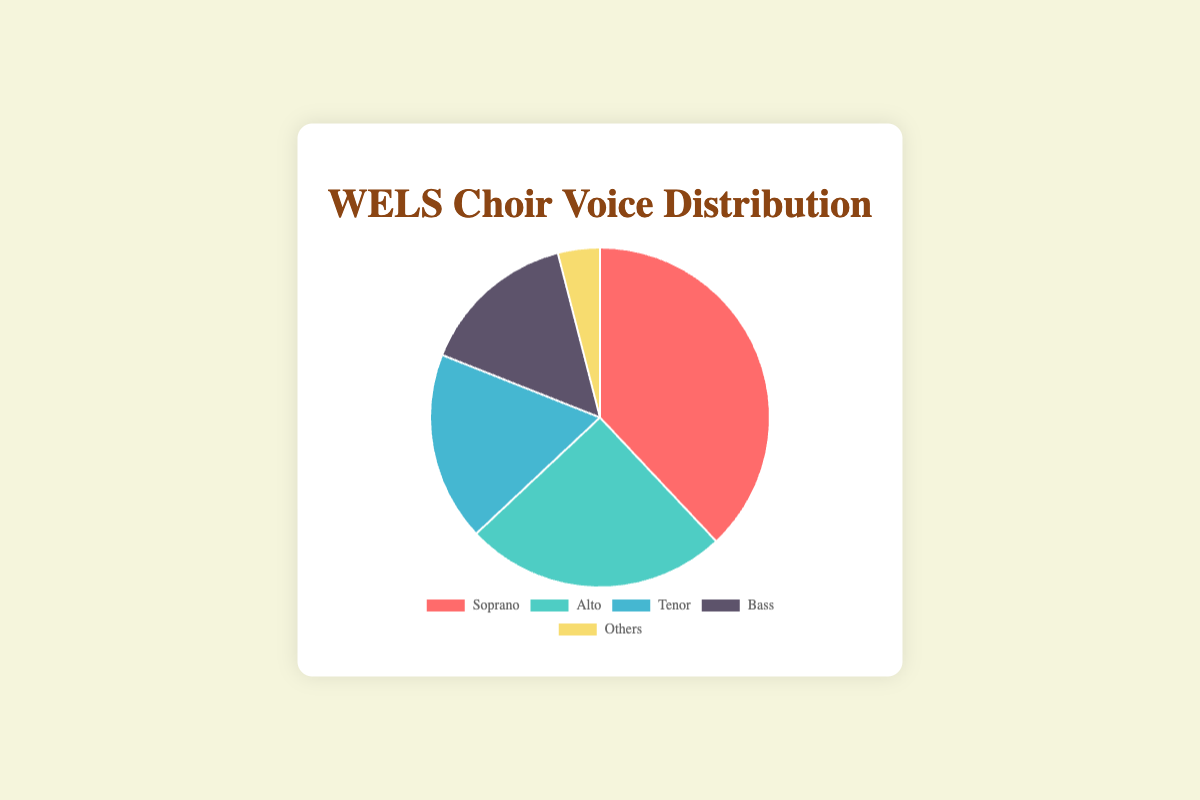What percentage of choir members are Sopranos? Look at the pie chart segment labeled "Soprano" and note the percentage value.
Answer: 38% Which voice part has the second highest percentage of choir members? Identify the second largest segment in the pie chart. The labels indicate "Alto" has the second highest percentage.
Answer: Alto What is the combined percentage of Tenors and Basses? Add the percentages of Tenors and Basses (18% + 15%).
Answer: 33% How much larger is the Soprano percentage compared to the "Others" category? Subtract the percentage of "Others" from the percentage of Sopranos (38% - 4%).
Answer: 34% Which color represents the Alto voice part in the chart? Observe the color associated with the respective label. The Alto section is represented in green.
Answer: green Is the percentage of Altos greater than the combined percentage of Basses and Others? Compare the percentage of Altos (25%) with the sum of Basses (15%) and Others (4%), which is 19%. 25% is greater than 19%.
Answer: Yes Arrange the voice parts in ascending order of their percentage. List the percentages from smallest to largest and match them with their voice parts: Others (4%), Bass (15%), Tenor (18%), Alto (25%), Soprano (38%).
Answer: Others, Bass, Tenor, Alto, Soprano Which voice part occupies roughly one-third of the pie chart? Check for a segment close to 33%. The closest is "Soprano" with 38%.
Answer: Soprano 